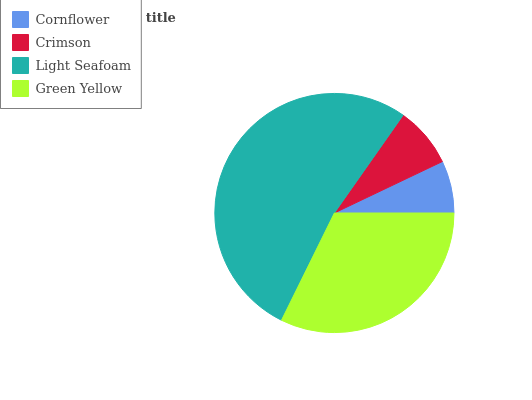Is Cornflower the minimum?
Answer yes or no. Yes. Is Light Seafoam the maximum?
Answer yes or no. Yes. Is Crimson the minimum?
Answer yes or no. No. Is Crimson the maximum?
Answer yes or no. No. Is Crimson greater than Cornflower?
Answer yes or no. Yes. Is Cornflower less than Crimson?
Answer yes or no. Yes. Is Cornflower greater than Crimson?
Answer yes or no. No. Is Crimson less than Cornflower?
Answer yes or no. No. Is Green Yellow the high median?
Answer yes or no. Yes. Is Crimson the low median?
Answer yes or no. Yes. Is Light Seafoam the high median?
Answer yes or no. No. Is Cornflower the low median?
Answer yes or no. No. 